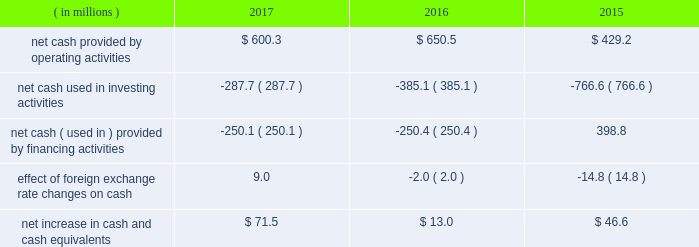Our operating cash flows are significantly impacted by the seasonality of our businesses .
We typically generate most of our operating cash flow in the third and fourth quarters of each year .
In june 2015 , we issued $ 900 million of senior notes in a registered public offering .
The senior notes consist of two tranches : $ 400 million of five-year notes due 2020 with a coupon of 3% ( 3 % ) and $ 500 million of ten-year notes due 2025 with a coupon of 4% ( 4 % ) .
We used the proceeds from the senior notes offering to pay down our revolving credit facility and for general corporate purposes .
On december 31 , 2017 , the outstanding amount of the senior notes , net of underwriting commissions and price discounts , was $ 892.6 million .
Cash flows below is a summary of cash flows for the years ended december 31 , 2017 , 2016 and 2015 .
( in millions ) 2017 2016 2015 .
Net cash provided by operating activities was $ 600.3 million in 2017 compared to $ 650.5 million in 2016 and $ 429.2 million in 2015 .
The $ 50.2 million decrease in cash provided by operating activities from 2017 to 2016 was primarily due to higher build in working capital , primarily driven by higher inventory purchases in 2017 , partially offset by a higher net income .
The $ 221.3 million increase in cash provided by operating activities from 2015 to 2016 was primarily due to a reduction in working capital in 2016 compared to 2015 and higher net income .
Net cash used in investing activities was $ 287.7 million in 2017 compared to $ 385.1 million in 2016 and $ 766.6 million in 2015 .
The decrease of $ 97.4 million from 2016 to 2017 was primarily due lower cost of acquisitions of $ 115.1 million , partially offset by $ 15.7 million of higher capital expenditures .
The decrease of $ 381.5 million from 2015 to 2016 was primarily due the decrease in cost of acquisitions of $ 413.1 million , partially offset by $ 20.8 million of higher capital spending .
Net cash used in financing activities was $ 250.1 million in 2017 compared to net cash used in financing activities of $ 250.4 million in 2016 and net cash provided by in financing activities of $ 398.8 million in 2015 .
The change of $ 649.2 million in 2016 compared to 2015 was primarily due to $ 372.8 million of higher share repurchases and lower net borrowings of $ 240.8 million .
Pension plans subsidiaries of fortune brands sponsor their respective defined benefit pension plans that are funded by a portfolio of investments maintained within our benefit plan trust .
In 2017 , 2016 and 2015 , we contributed $ 28.4 million , zero and $ 2.3 million , respectively , to qualified pension plans .
In 2018 , we expect to make pension contributions of approximately $ 12.8 million .
As of december 31 , 2017 , the fair value of our total pension plan assets was $ 656.6 million , representing funding of 79% ( 79 % ) of the accumulated benefit obligation liability .
For the foreseeable future , we believe that we have sufficient liquidity to meet the minimum funding that may be required by the pension protection act of 2006 .
Foreign exchange we have operations in various foreign countries , principally canada , china , mexico , the united kingdom , france , australia and japan .
Therefore , changes in the value of the related currencies affect our financial statements when translated into u.s .
Dollars. .
\\nin june 2015 what was the percent of the five-year notes due 2020 with a coupon of 3% ( 3 % ) of senior notes in a registered public offering? 
Computations: (400 / 900)
Answer: 0.44444. 